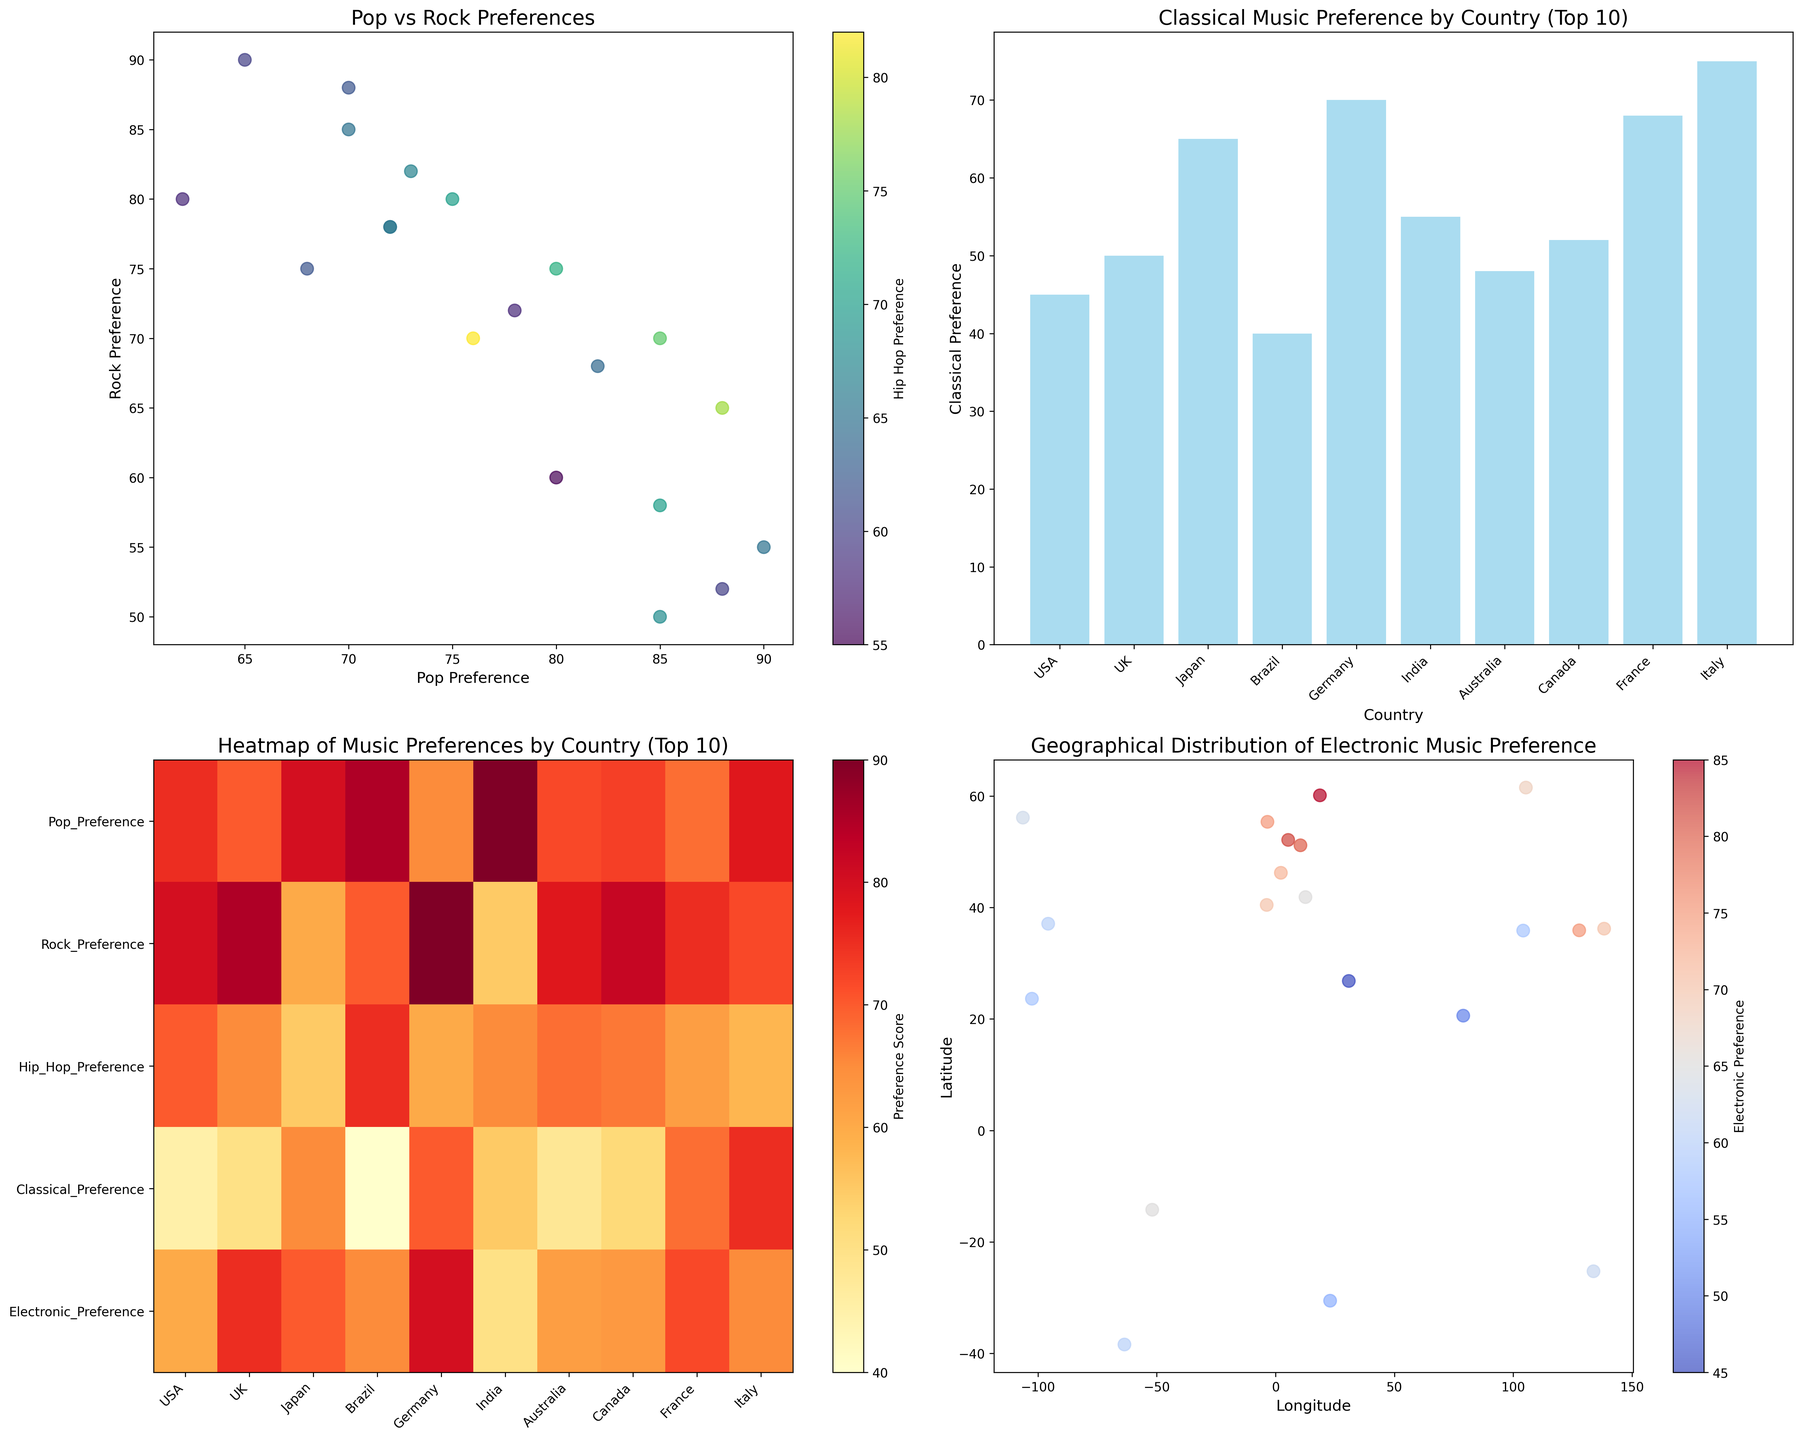how do preferences for Pop and Rock music compare across the visualized countries? By examining the scatter plot in the top-left subplot, it shows that USA and UK have high preferences for both Pop and Rock music, while countries like Germany and Sweden have a higher preference for Rock compared to Pop.
Answer: Pop and Rock preferences vary, with USA and UK showing high preferences for both Which country among the top 10 listed has the highest classical music preference? In the bar plot in the top-right subplot, Italy has the highest bar compared to other countries, indicating that Italy has the highest classical music preference among the top 10 countries listed.
Answer: Italy What is the relationship between Hip Hop preference and Pop preference as visualized in the scatter plot? The scatter plot in the top-left subplot uses color to represent Hip Hop preference. Observing the color gradient, higher Hip Hop preferences tend to correspond with higher Pop preferences, as countries with higher Pop preferences show darker colors.
Answer: Positive relationship How do preferences for Electronic music vary by geographical location? The geographical scatter plot in the bottom-right subplot shows variance in Electronic music preferences using color. Warmer colors (reds and oranges) indicate higher preferences, while cooler colors (blues) show lower preferences. Sweden, Germany, and the Netherlands have high preferences shown in warmer colors.
Answer: Varies by location with Sweden, Germany, and Netherlands having high preferences Which country has the lowest preference for Hip Hop music? By examining the scatter plots and comparing the scatter dots' associated Hip Hop preferences (colors), Japan stands out with a lower Hip Hop preference compared to other countries.
Answer: Japan In the heatmap of music preferences, which music preference has the highest average score across the top 10 countries? Calculating the average values from the heatmap in the bottom-left subplot involves summing the values for each music preference category and dividing by the number of countries. Pop shows higher intensity cells indicating a higher average score.
Answer: Pop What is the average Rock preference of Brazil and Argentina? Reading values from the data table, Brazil has a Rock preference of 70, and Argentina has 75. The average is calculated as (70 + 75) / 2 = 72.5.
Answer: 72.5 Which country located in Eastern Europe shows a high Electronic Music preference? Looking at the geographical scatter plot in the bottom-right subplot, Russia, located in Eastern Europe, is represented by a scatter dot with a warm color indicative of high Electronic music preference.
Answer: Russia Do countries closer to the equator show higher or lower preferences for Classical music? In the bar plot focusing on Classical music preference, countries like Brazil and Mexico, which are closer to the equator, show lower bars indicative of lower preferences for Classical music.
Answer: Lower preferences Among the countries listed, which has the widest range of music preferences? By examining the heatmap, Germany exhibits high variance in intensity across different cells indicating a wide range of preferences from high Rock and Electronic to lower Pop.
Answer: Germany 